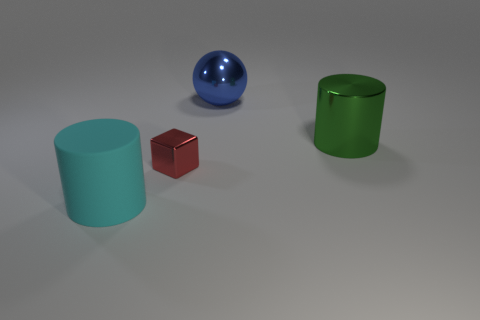Add 1 green metal cylinders. How many objects exist? 5 Subtract all balls. How many objects are left? 3 Add 3 red blocks. How many red blocks are left? 4 Add 3 metal spheres. How many metal spheres exist? 4 Subtract 1 green cylinders. How many objects are left? 3 Subtract all tiny purple matte blocks. Subtract all red metal blocks. How many objects are left? 3 